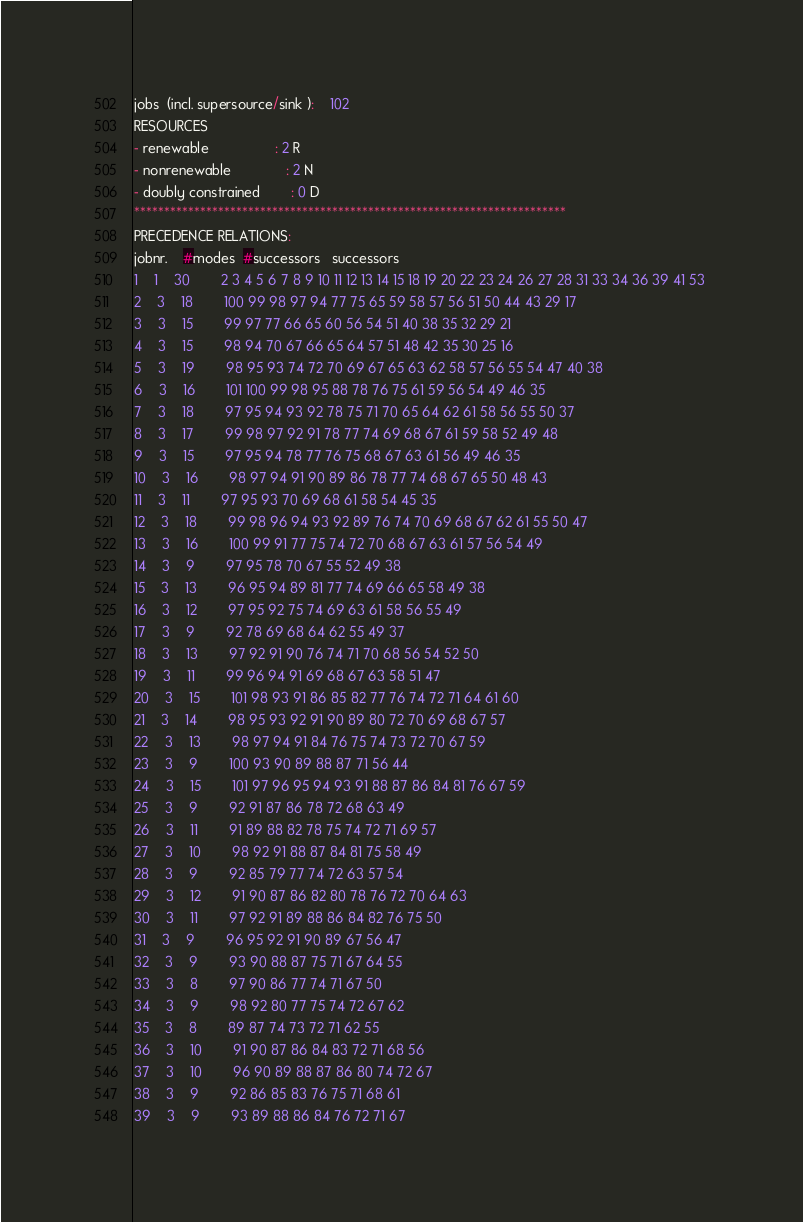<code> <loc_0><loc_0><loc_500><loc_500><_ObjectiveC_>jobs  (incl. supersource/sink ):	102
RESOURCES
- renewable                 : 2 R
- nonrenewable              : 2 N
- doubly constrained        : 0 D
************************************************************************
PRECEDENCE RELATIONS:
jobnr.    #modes  #successors   successors
1	1	30		2 3 4 5 6 7 8 9 10 11 12 13 14 15 18 19 20 22 23 24 26 27 28 31 33 34 36 39 41 53 
2	3	18		100 99 98 97 94 77 75 65 59 58 57 56 51 50 44 43 29 17 
3	3	15		99 97 77 66 65 60 56 54 51 40 38 35 32 29 21 
4	3	15		98 94 70 67 66 65 64 57 51 48 42 35 30 25 16 
5	3	19		98 95 93 74 72 70 69 67 65 63 62 58 57 56 55 54 47 40 38 
6	3	16		101 100 99 98 95 88 78 76 75 61 59 56 54 49 46 35 
7	3	18		97 95 94 93 92 78 75 71 70 65 64 62 61 58 56 55 50 37 
8	3	17		99 98 97 92 91 78 77 74 69 68 67 61 59 58 52 49 48 
9	3	15		97 95 94 78 77 76 75 68 67 63 61 56 49 46 35 
10	3	16		98 97 94 91 90 89 86 78 77 74 68 67 65 50 48 43 
11	3	11		97 95 93 70 69 68 61 58 54 45 35 
12	3	18		99 98 96 94 93 92 89 76 74 70 69 68 67 62 61 55 50 47 
13	3	16		100 99 91 77 75 74 72 70 68 67 63 61 57 56 54 49 
14	3	9		97 95 78 70 67 55 52 49 38 
15	3	13		96 95 94 89 81 77 74 69 66 65 58 49 38 
16	3	12		97 95 92 75 74 69 63 61 58 56 55 49 
17	3	9		92 78 69 68 64 62 55 49 37 
18	3	13		97 92 91 90 76 74 71 70 68 56 54 52 50 
19	3	11		99 96 94 91 69 68 67 63 58 51 47 
20	3	15		101 98 93 91 86 85 82 77 76 74 72 71 64 61 60 
21	3	14		98 95 93 92 91 90 89 80 72 70 69 68 67 57 
22	3	13		98 97 94 91 84 76 75 74 73 72 70 67 59 
23	3	9		100 93 90 89 88 87 71 56 44 
24	3	15		101 97 96 95 94 93 91 88 87 86 84 81 76 67 59 
25	3	9		92 91 87 86 78 72 68 63 49 
26	3	11		91 89 88 82 78 75 74 72 71 69 57 
27	3	10		98 92 91 88 87 84 81 75 58 49 
28	3	9		92 85 79 77 74 72 63 57 54 
29	3	12		91 90 87 86 82 80 78 76 72 70 64 63 
30	3	11		97 92 91 89 88 86 84 82 76 75 50 
31	3	9		96 95 92 91 90 89 67 56 47 
32	3	9		93 90 88 87 75 71 67 64 55 
33	3	8		97 90 86 77 74 71 67 50 
34	3	9		98 92 80 77 75 74 72 67 62 
35	3	8		89 87 74 73 72 71 62 55 
36	3	10		91 90 87 86 84 83 72 71 68 56 
37	3	10		96 90 89 88 87 86 80 74 72 67 
38	3	9		92 86 85 83 76 75 71 68 61 
39	3	9		93 89 88 86 84 76 72 71 67 </code> 